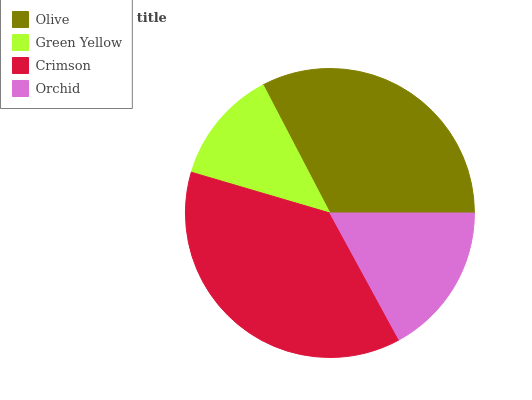Is Green Yellow the minimum?
Answer yes or no. Yes. Is Crimson the maximum?
Answer yes or no. Yes. Is Crimson the minimum?
Answer yes or no. No. Is Green Yellow the maximum?
Answer yes or no. No. Is Crimson greater than Green Yellow?
Answer yes or no. Yes. Is Green Yellow less than Crimson?
Answer yes or no. Yes. Is Green Yellow greater than Crimson?
Answer yes or no. No. Is Crimson less than Green Yellow?
Answer yes or no. No. Is Olive the high median?
Answer yes or no. Yes. Is Orchid the low median?
Answer yes or no. Yes. Is Orchid the high median?
Answer yes or no. No. Is Olive the low median?
Answer yes or no. No. 